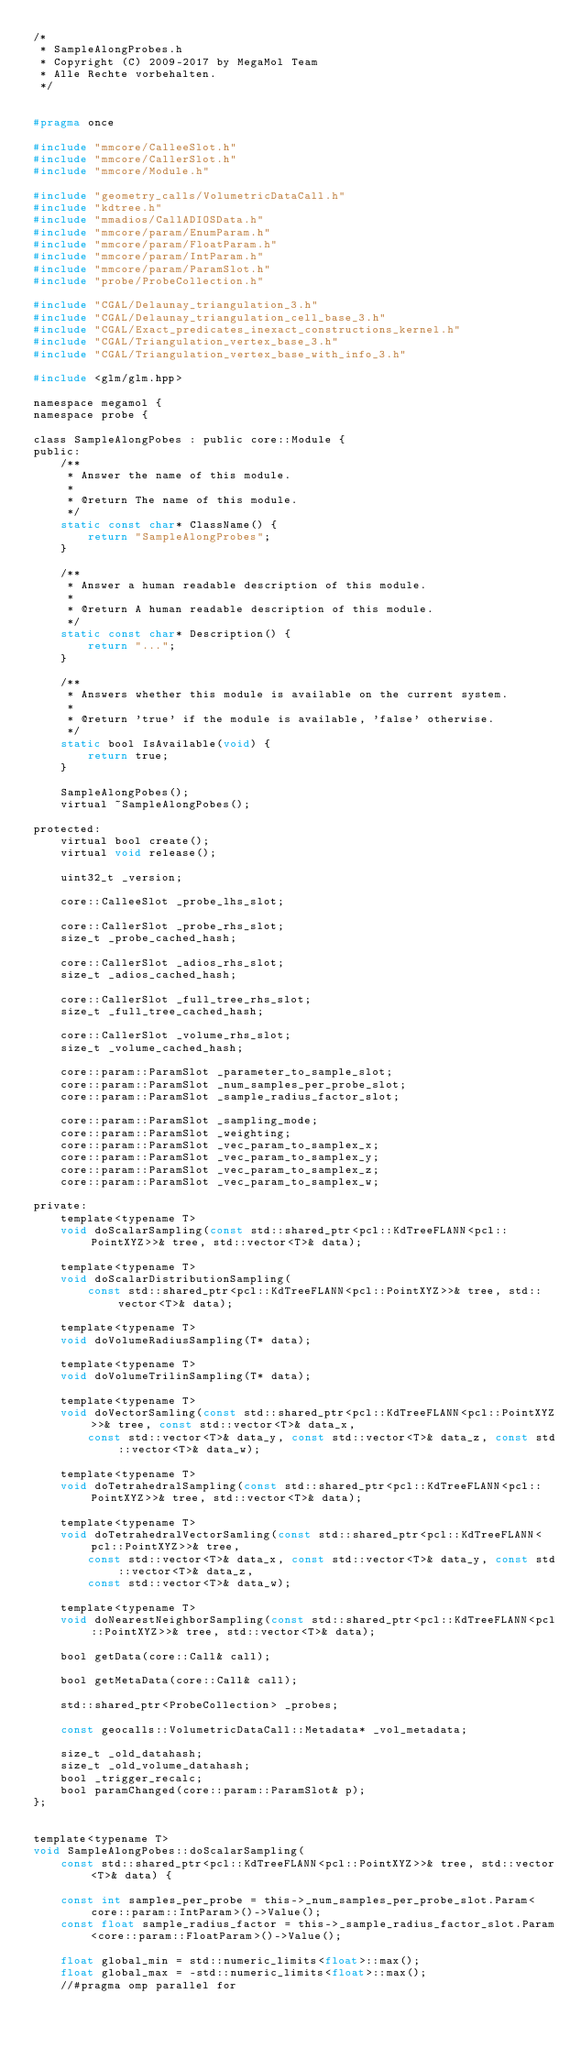Convert code to text. <code><loc_0><loc_0><loc_500><loc_500><_C_>/*
 * SampleAlongProbes.h
 * Copyright (C) 2009-2017 by MegaMol Team
 * Alle Rechte vorbehalten.
 */


#pragma once

#include "mmcore/CalleeSlot.h"
#include "mmcore/CallerSlot.h"
#include "mmcore/Module.h"

#include "geometry_calls/VolumetricDataCall.h"
#include "kdtree.h"
#include "mmadios/CallADIOSData.h"
#include "mmcore/param/EnumParam.h"
#include "mmcore/param/FloatParam.h"
#include "mmcore/param/IntParam.h"
#include "mmcore/param/ParamSlot.h"
#include "probe/ProbeCollection.h"

#include "CGAL/Delaunay_triangulation_3.h"
#include "CGAL/Delaunay_triangulation_cell_base_3.h"
#include "CGAL/Exact_predicates_inexact_constructions_kernel.h"
#include "CGAL/Triangulation_vertex_base_3.h"
#include "CGAL/Triangulation_vertex_base_with_info_3.h"

#include <glm/glm.hpp>

namespace megamol {
namespace probe {

class SampleAlongPobes : public core::Module {
public:
    /**
     * Answer the name of this module.
     *
     * @return The name of this module.
     */
    static const char* ClassName() {
        return "SampleAlongProbes";
    }

    /**
     * Answer a human readable description of this module.
     *
     * @return A human readable description of this module.
     */
    static const char* Description() {
        return "...";
    }

    /**
     * Answers whether this module is available on the current system.
     *
     * @return 'true' if the module is available, 'false' otherwise.
     */
    static bool IsAvailable(void) {
        return true;
    }

    SampleAlongPobes();
    virtual ~SampleAlongPobes();

protected:
    virtual bool create();
    virtual void release();

    uint32_t _version;

    core::CalleeSlot _probe_lhs_slot;

    core::CallerSlot _probe_rhs_slot;
    size_t _probe_cached_hash;

    core::CallerSlot _adios_rhs_slot;
    size_t _adios_cached_hash;

    core::CallerSlot _full_tree_rhs_slot;
    size_t _full_tree_cached_hash;

    core::CallerSlot _volume_rhs_slot;
    size_t _volume_cached_hash;

    core::param::ParamSlot _parameter_to_sample_slot;
    core::param::ParamSlot _num_samples_per_probe_slot;
    core::param::ParamSlot _sample_radius_factor_slot;

    core::param::ParamSlot _sampling_mode;
    core::param::ParamSlot _weighting;
    core::param::ParamSlot _vec_param_to_samplex_x;
    core::param::ParamSlot _vec_param_to_samplex_y;
    core::param::ParamSlot _vec_param_to_samplex_z;
    core::param::ParamSlot _vec_param_to_samplex_w;

private:
    template<typename T>
    void doScalarSampling(const std::shared_ptr<pcl::KdTreeFLANN<pcl::PointXYZ>>& tree, std::vector<T>& data);

    template<typename T>
    void doScalarDistributionSampling(
        const std::shared_ptr<pcl::KdTreeFLANN<pcl::PointXYZ>>& tree, std::vector<T>& data);

    template<typename T>
    void doVolumeRadiusSampling(T* data);

    template<typename T>
    void doVolumeTrilinSampling(T* data);

    template<typename T>
    void doVectorSamling(const std::shared_ptr<pcl::KdTreeFLANN<pcl::PointXYZ>>& tree, const std::vector<T>& data_x,
        const std::vector<T>& data_y, const std::vector<T>& data_z, const std::vector<T>& data_w);

    template<typename T>
    void doTetrahedralSampling(const std::shared_ptr<pcl::KdTreeFLANN<pcl::PointXYZ>>& tree, std::vector<T>& data);

    template<typename T>
    void doTetrahedralVectorSamling(const std::shared_ptr<pcl::KdTreeFLANN<pcl::PointXYZ>>& tree,
        const std::vector<T>& data_x, const std::vector<T>& data_y, const std::vector<T>& data_z,
        const std::vector<T>& data_w);

    template<typename T>
    void doNearestNeighborSampling(const std::shared_ptr<pcl::KdTreeFLANN<pcl::PointXYZ>>& tree, std::vector<T>& data);

    bool getData(core::Call& call);

    bool getMetaData(core::Call& call);

    std::shared_ptr<ProbeCollection> _probes;

    const geocalls::VolumetricDataCall::Metadata* _vol_metadata;

    size_t _old_datahash;
    size_t _old_volume_datahash;
    bool _trigger_recalc;
    bool paramChanged(core::param::ParamSlot& p);
};


template<typename T>
void SampleAlongPobes::doScalarSampling(
    const std::shared_ptr<pcl::KdTreeFLANN<pcl::PointXYZ>>& tree, std::vector<T>& data) {

    const int samples_per_probe = this->_num_samples_per_probe_slot.Param<core::param::IntParam>()->Value();
    const float sample_radius_factor = this->_sample_radius_factor_slot.Param<core::param::FloatParam>()->Value();

    float global_min = std::numeric_limits<float>::max();
    float global_max = -std::numeric_limits<float>::max();
    //#pragma omp parallel for</code> 